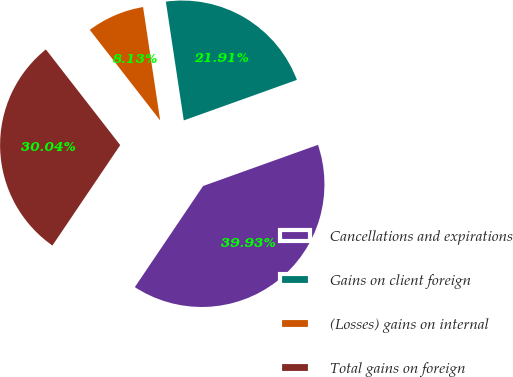<chart> <loc_0><loc_0><loc_500><loc_500><pie_chart><fcel>Cancellations and expirations<fcel>Gains on client foreign<fcel>(Losses) gains on internal<fcel>Total gains on foreign<nl><fcel>39.93%<fcel>21.91%<fcel>8.13%<fcel>30.04%<nl></chart> 